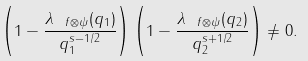<formula> <loc_0><loc_0><loc_500><loc_500>\left ( 1 - \frac { \lambda _ { \ f \otimes \psi } ( q _ { 1 } ) } { q _ { 1 } ^ { s - 1 / 2 } } \right ) \left ( 1 - \frac { \lambda _ { \ f \otimes \psi } ( q _ { 2 } ) } { q _ { 2 } ^ { s + 1 / 2 } } \right ) \neq 0 .</formula> 